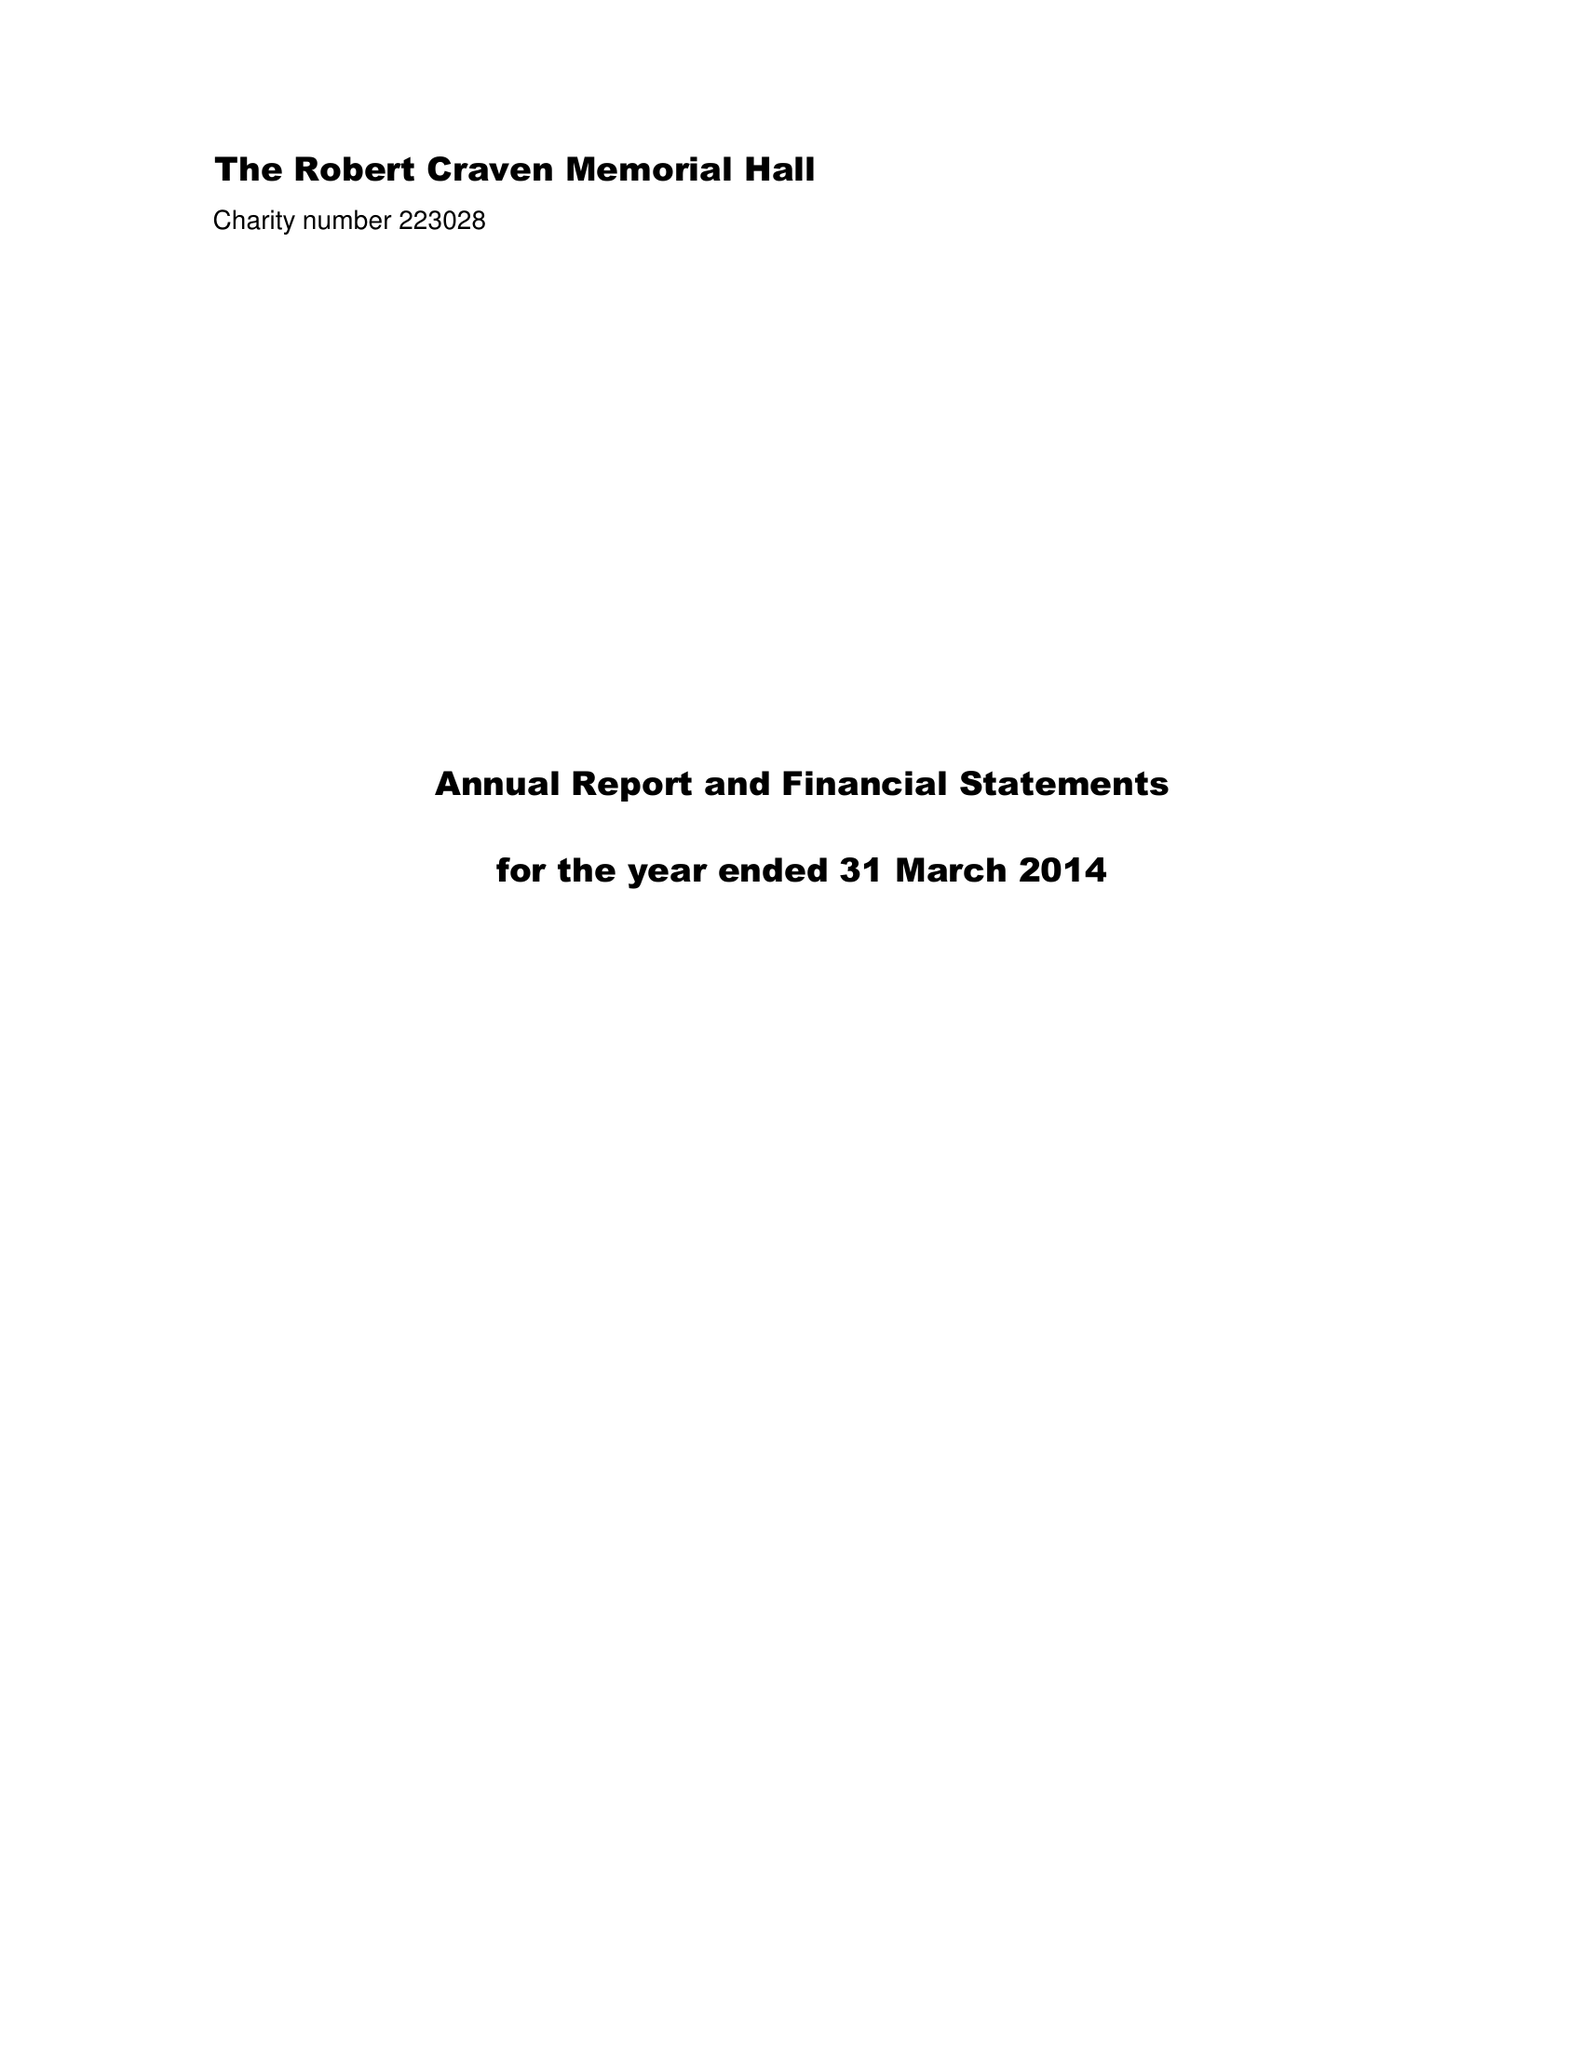What is the value for the charity_name?
Answer the question using a single word or phrase. The Robert Craven Memorial Hall 